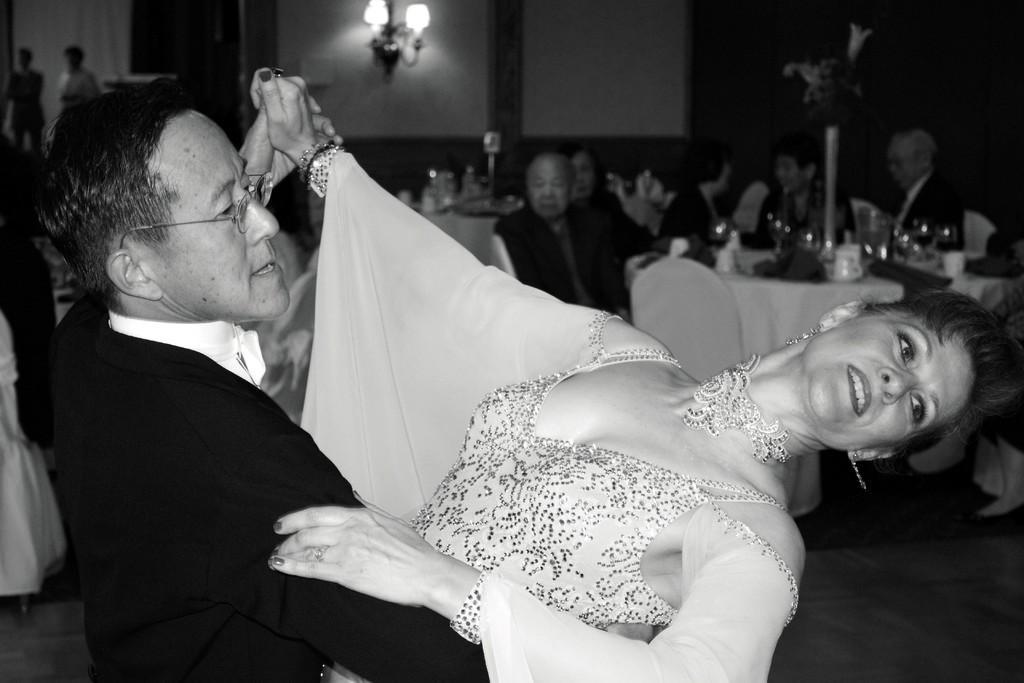How would you summarize this image in a sentence or two? In this picture one old man and one old women are dancing and some people are sitting back side. 